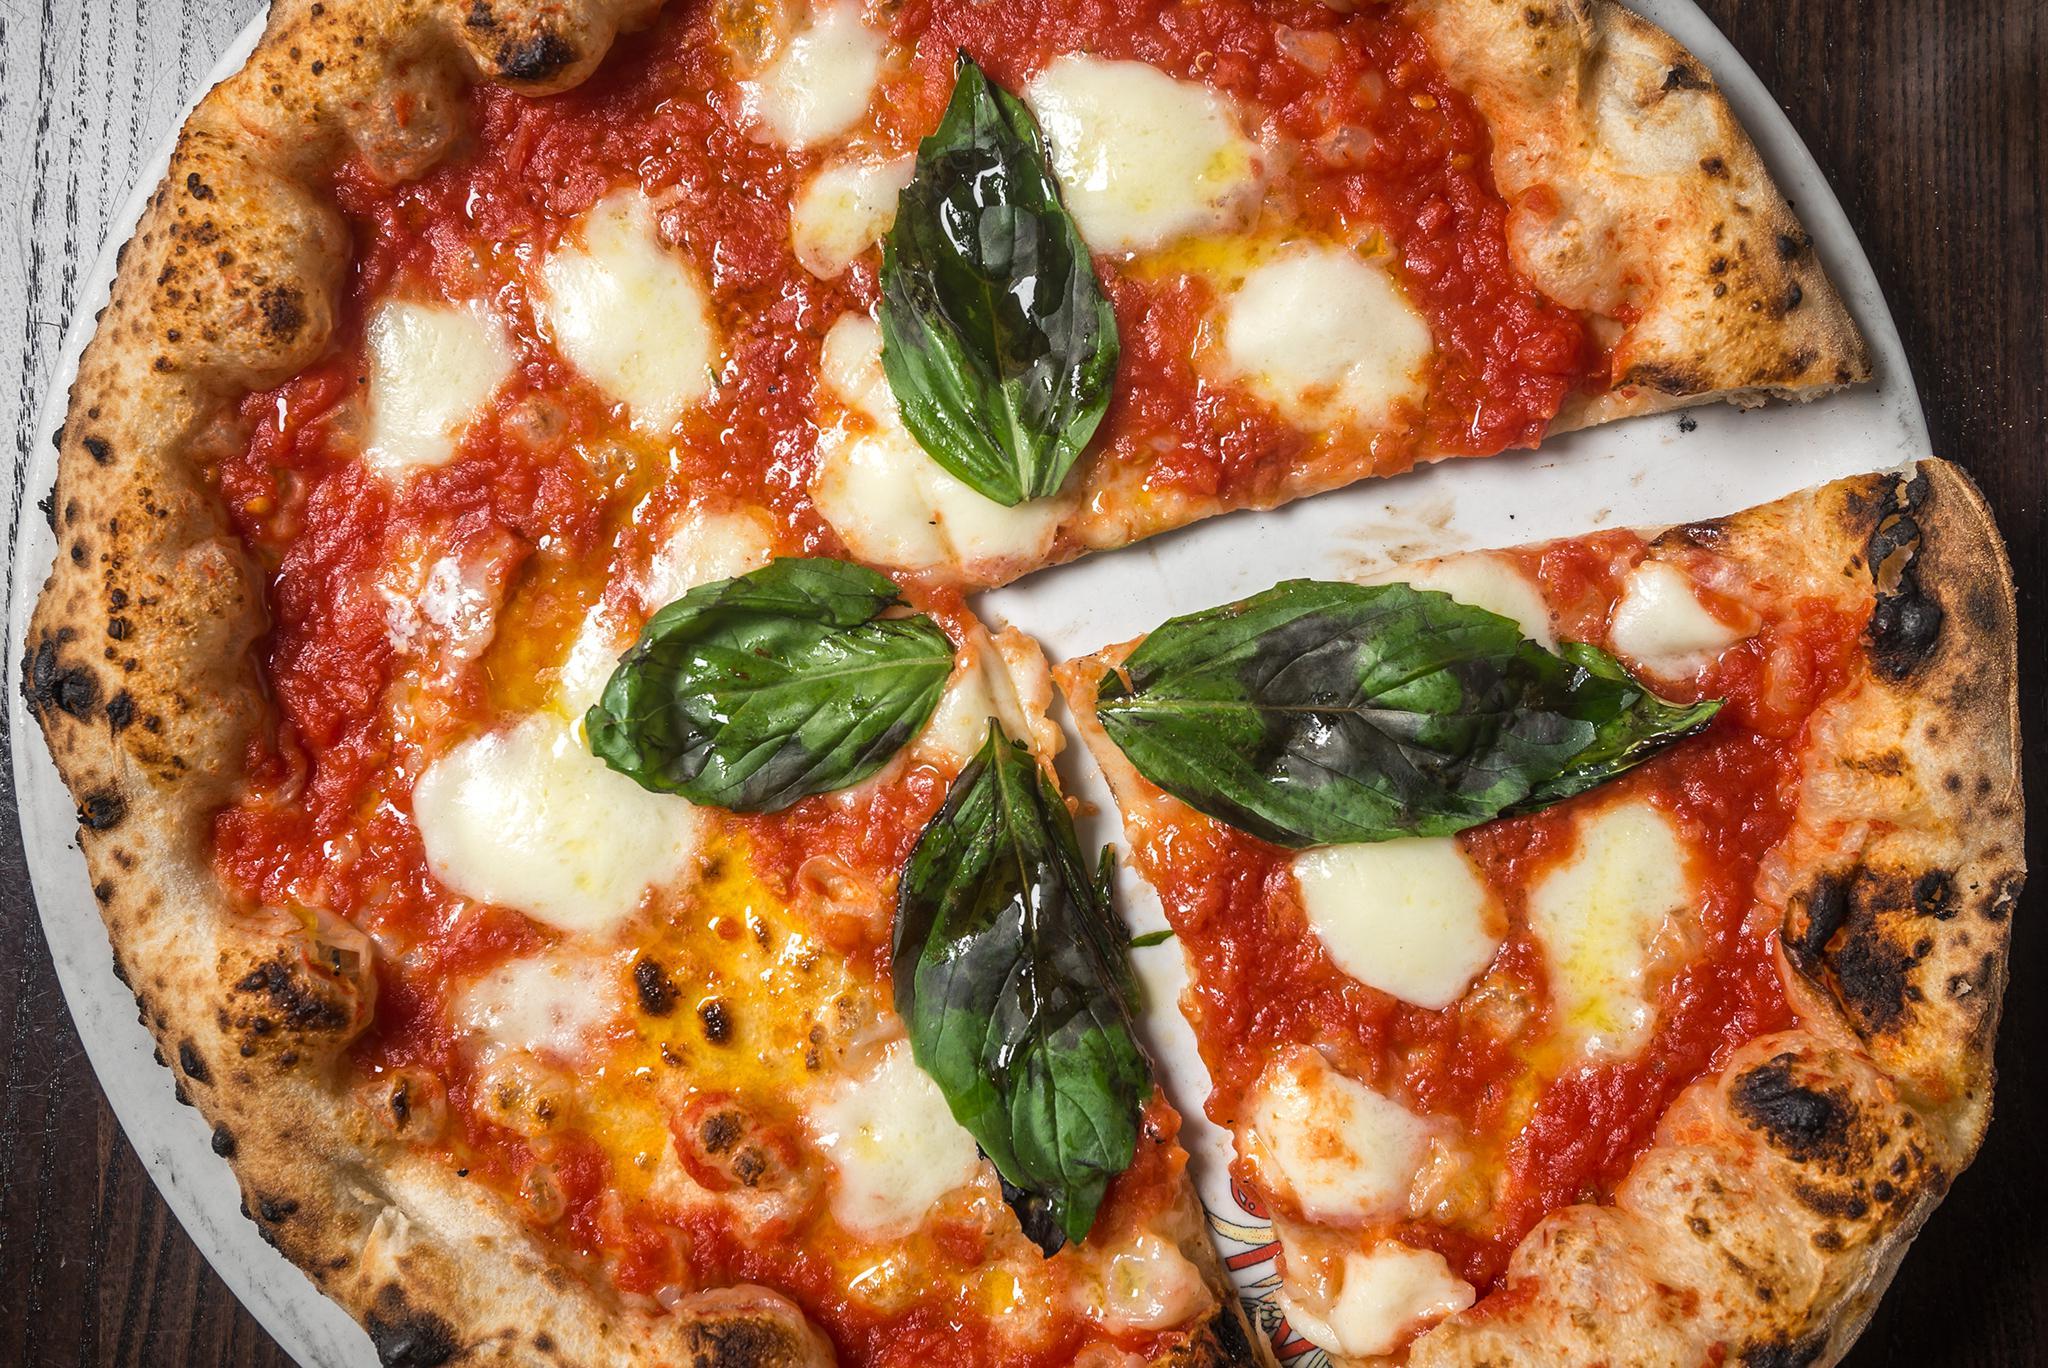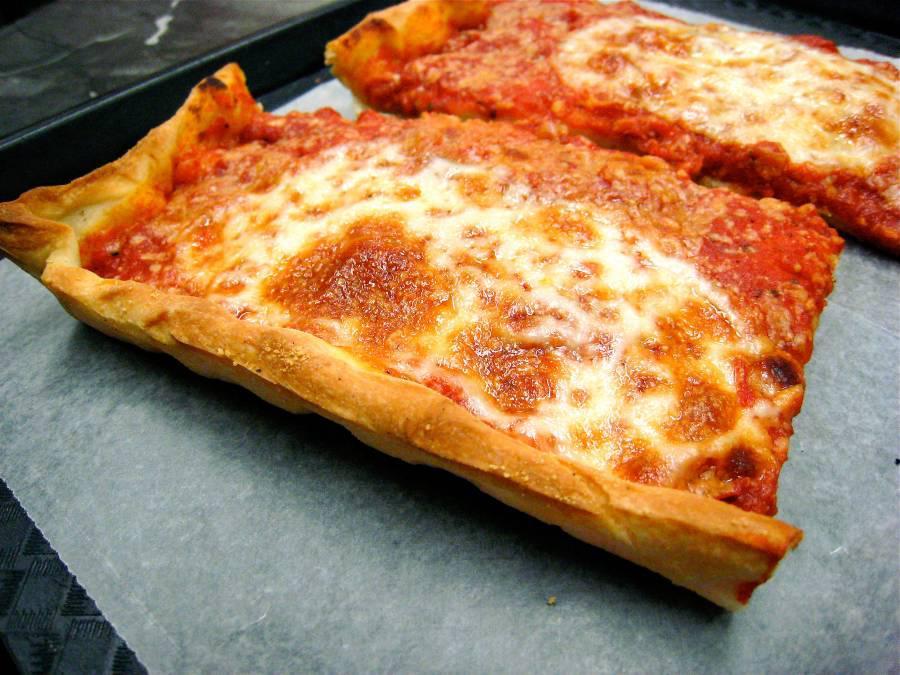The first image is the image on the left, the second image is the image on the right. Assess this claim about the two images: "There are pepperoni slices on top of the cheese layer on the pizza.". Correct or not? Answer yes or no. No. The first image is the image on the left, the second image is the image on the right. Considering the images on both sides, is "None of the pizza shown has pepperoni on it." valid? Answer yes or no. Yes. 